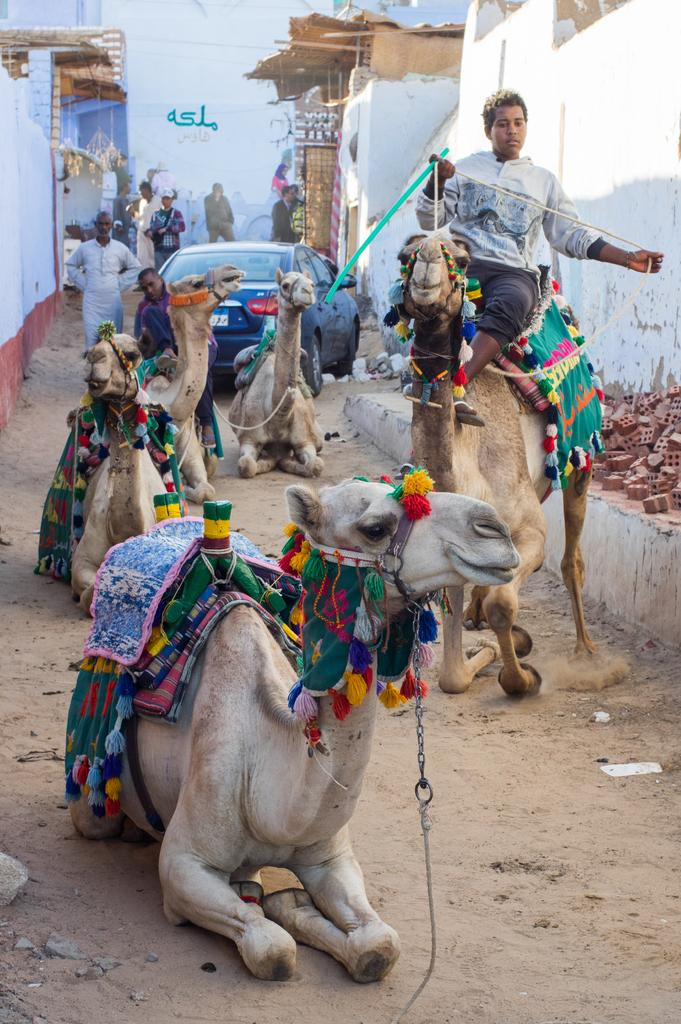What animals can be seen on the path in the image? There are camels on the path in the image. What is the person in the image doing? A person is sitting on one of the camels. What type of vehicle is present in the image? There is a car in the image. Can you describe the group of people in the image? There is a group of people standing in the image. What type of structures can be seen in the image? There are buildings in the image. What material is present in the image? Bricks are present in the image. What type of juice can be seen being served in the image? There is no juice present in the image. What kind of tent is set up near the buildings in the image? There is no tent present in the image. 